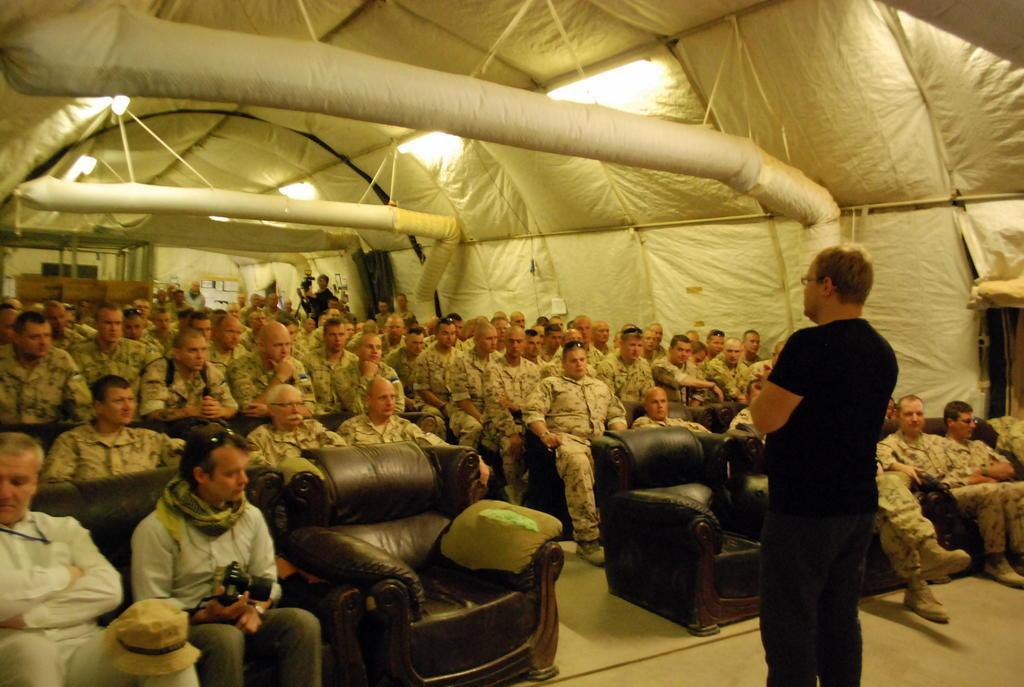Could you give a brief overview of what you see in this image? Here in this picture we can see a crowd of people are sitting. And to the front row left corner there is a man sitting ,there is a hat on knee. To the beside of him there is man sitting and he is holding a camera, around his neck there is a stole. And there is black sofa. In front all of them there is man standing with black color t-shirt. And we can top of that there is light. And to the last corner there is a man holding a video camera. 